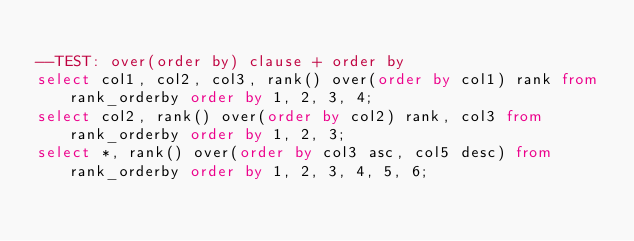Convert code to text. <code><loc_0><loc_0><loc_500><loc_500><_SQL_>
--TEST: over(order by) clause + order by
select col1, col2, col3, rank() over(order by col1) rank from rank_orderby order by 1, 2, 3, 4;
select col2, rank() over(order by col2) rank, col3 from rank_orderby order by 1, 2, 3;
select *, rank() over(order by col3 asc, col5 desc) from rank_orderby order by 1, 2, 3, 4, 5, 6;</code> 